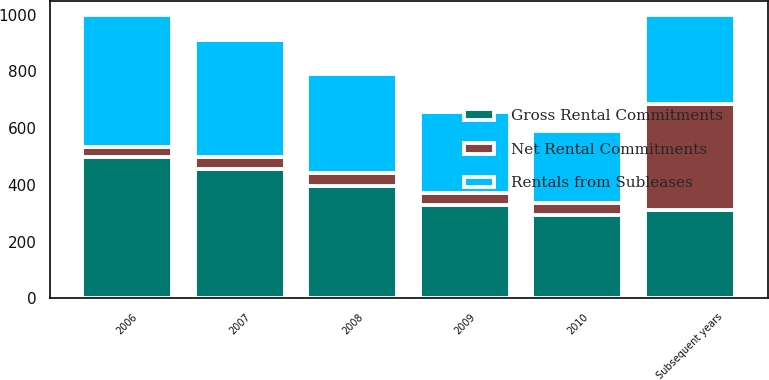<chart> <loc_0><loc_0><loc_500><loc_500><stacked_bar_chart><ecel><fcel>2006<fcel>2007<fcel>2008<fcel>2009<fcel>2010<fcel>Subsequent years<nl><fcel>Gross Rental Commitments<fcel>499<fcel>455<fcel>396<fcel>329<fcel>295<fcel>312<nl><fcel>Net Rental Commitments<fcel>33<fcel>44<fcel>44<fcel>41<fcel>41<fcel>374<nl><fcel>Rentals from Subleases<fcel>466<fcel>411<fcel>352<fcel>288<fcel>254<fcel>312<nl></chart> 